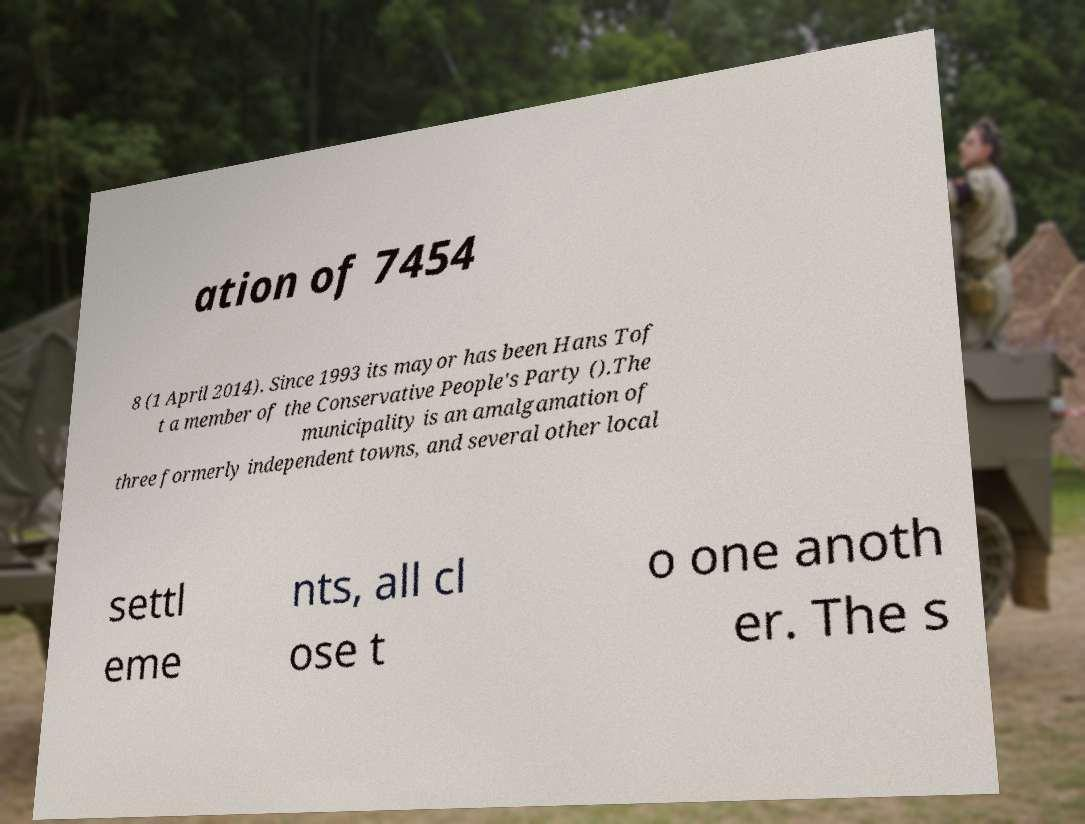Please read and relay the text visible in this image. What does it say? ation of 7454 8 (1 April 2014). Since 1993 its mayor has been Hans Tof t a member of the Conservative People's Party ().The municipality is an amalgamation of three formerly independent towns, and several other local settl eme nts, all cl ose t o one anoth er. The s 